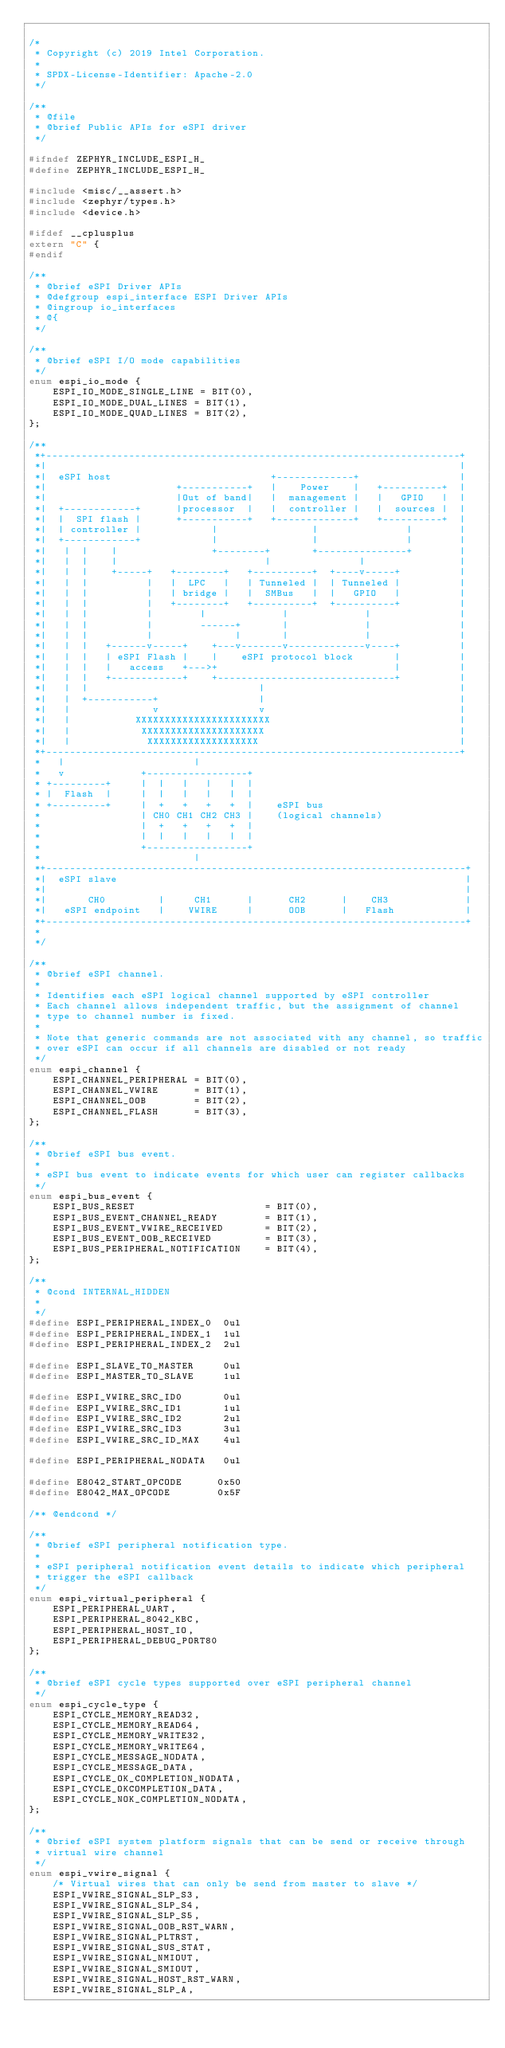Convert code to text. <code><loc_0><loc_0><loc_500><loc_500><_C_>
/*
 * Copyright (c) 2019 Intel Corporation.
 *
 * SPDX-License-Identifier: Apache-2.0
 */

/**
 * @file
 * @brief Public APIs for eSPI driver
 */

#ifndef ZEPHYR_INCLUDE_ESPI_H_
#define ZEPHYR_INCLUDE_ESPI_H_

#include <misc/__assert.h>
#include <zephyr/types.h>
#include <device.h>

#ifdef __cplusplus
extern "C" {
#endif

/**
 * @brief eSPI Driver APIs
 * @defgroup espi_interface ESPI Driver APIs
 * @ingroup io_interfaces
 * @{
 */

/**
 * @brief eSPI I/O mode capabilities
 */
enum espi_io_mode {
	ESPI_IO_MODE_SINGLE_LINE = BIT(0),
	ESPI_IO_MODE_DUAL_LINES = BIT(1),
	ESPI_IO_MODE_QUAD_LINES = BIT(2),
};

/**
 *+----------------------------------------------------------------------+
 *|                                                                      |
 *|  eSPI host                           +-------------+                 |
 *|                      +-----------+   |    Power    |   +----------+  |
 *|                      |Out of band|   |  management |   |   GPIO   |  |
 *|  +------------+      |processor  |   |  controller |   |  sources |  |
 *|  |  SPI flash |      +-----------+   +-------------+   +----------+  |
 *|  | controller |            |                |               |        |
 *|  +------------+            |                |               |        |
 *|   |  |    |                +--------+       +---------------+        |
 *|   |  |    |                         |               |                |
 *|   |  |    +-----+   +--------+   +----------+  +----v-----+          |
 *|   |  |          |   |  LPC   |   | Tunneled |  | Tunneled |          |
 *|   |  |          |   | bridge |   |  SMBus   |  |   GPIO   |          |
 *|   |  |          |   +--------+   +----------+  +----------+          |
 *|   |  |          |        |             |             |               |
 *|   |  |          |        ------+       |             |               |
 *|   |  |          |              |       |             |               |
 *|   |  |   +------v-----+    +---v-------v-------------v----+          |
 *|   |  |   | eSPI Flash |    |    eSPI protocol block       |          |
 *|   |  |   |   access   +--->+                              |          |
 *|   |  |   +------------+    +------------------------------+          |
 *|   |  |                             |                                 |
 *|   |  +-----------+                 |                                 |
 *|   |              v                 v                                 |
 *|   |           XXXXXXXXXXXXXXXXXXXXXXX                                |
 *|   |            XXXXXXXXXXXXXXXXXXXXX                                 |
 *|   |             XXXXXXXXXXXXXXXXXXX                                  |
 *+----------------------------------------------------------------------+
 *   |                      |
 *   v             +-----------------+
 * +---------+     |  |   |   |   |  |
 * |  Flash  |     |  |   |   |   |  |
 * +---------+     |  +   +   +   +  |    eSPI bus
 *                 | CH0 CH1 CH2 CH3 |    (logical channels)
 *                 |  +   +   +   +  |
 *                 |  |   |   |   |  |
 *                 +-----------------+
 *                          |
 *+-----------------------------------------------------------------------+
 *|  eSPI slave                                                           |
 *|                                                                       |
 *|       CH0         |     CH1      |      CH2      |    CH3             |
 *|   eSPI endpoint   |    VWIRE     |      OOB      |   Flash            |
 *+-----------------------------------------------------------------------+
 *
 */

/**
 * @brief eSPI channel.
 *
 * Identifies each eSPI logical channel supported by eSPI controller
 * Each channel allows independent traffic, but the assignment of channel
 * type to channel number is fixed.
 *
 * Note that generic commands are not associated with any channel, so traffic
 * over eSPI can occur if all channels are disabled or not ready
 */
enum espi_channel {
	ESPI_CHANNEL_PERIPHERAL = BIT(0),
	ESPI_CHANNEL_VWIRE      = BIT(1),
	ESPI_CHANNEL_OOB        = BIT(2),
	ESPI_CHANNEL_FLASH      = BIT(3),
};

/**
 * @brief eSPI bus event.
 *
 * eSPI bus event to indicate events for which user can register callbacks
 */
enum espi_bus_event {
	ESPI_BUS_RESET                      = BIT(0),
	ESPI_BUS_EVENT_CHANNEL_READY        = BIT(1),
	ESPI_BUS_EVENT_VWIRE_RECEIVED       = BIT(2),
	ESPI_BUS_EVENT_OOB_RECEIVED         = BIT(3),
	ESPI_BUS_PERIPHERAL_NOTIFICATION    = BIT(4),
};

/**
 * @cond INTERNAL_HIDDEN
 *
 */
#define ESPI_PERIPHERAL_INDEX_0  0ul
#define ESPI_PERIPHERAL_INDEX_1  1ul
#define ESPI_PERIPHERAL_INDEX_2  2ul

#define ESPI_SLAVE_TO_MASTER     0ul
#define ESPI_MASTER_TO_SLAVE     1ul

#define ESPI_VWIRE_SRC_ID0       0ul
#define ESPI_VWIRE_SRC_ID1       1ul
#define ESPI_VWIRE_SRC_ID2       2ul
#define ESPI_VWIRE_SRC_ID3       3ul
#define ESPI_VWIRE_SRC_ID_MAX    4ul

#define ESPI_PERIPHERAL_NODATA   0ul

#define E8042_START_OPCODE      0x50
#define E8042_MAX_OPCODE        0x5F

/** @endcond */

/**
 * @brief eSPI peripheral notification type.
 *
 * eSPI peripheral notification event details to indicate which peripheral
 * trigger the eSPI callback
 */
enum espi_virtual_peripheral {
	ESPI_PERIPHERAL_UART,
	ESPI_PERIPHERAL_8042_KBC,
	ESPI_PERIPHERAL_HOST_IO,
	ESPI_PERIPHERAL_DEBUG_PORT80
};

/**
 * @brief eSPI cycle types supported over eSPI peripheral channel
 */
enum espi_cycle_type {
	ESPI_CYCLE_MEMORY_READ32,
	ESPI_CYCLE_MEMORY_READ64,
	ESPI_CYCLE_MEMORY_WRITE32,
	ESPI_CYCLE_MEMORY_WRITE64,
	ESPI_CYCLE_MESSAGE_NODATA,
	ESPI_CYCLE_MESSAGE_DATA,
	ESPI_CYCLE_OK_COMPLETION_NODATA,
	ESPI_CYCLE_OKCOMPLETION_DATA,
	ESPI_CYCLE_NOK_COMPLETION_NODATA,
};

/**
 * @brief eSPI system platform signals that can be send or receive through
 * virtual wire channel
 */
enum espi_vwire_signal {
	/* Virtual wires that can only be send from master to slave */
	ESPI_VWIRE_SIGNAL_SLP_S3,
	ESPI_VWIRE_SIGNAL_SLP_S4,
	ESPI_VWIRE_SIGNAL_SLP_S5,
	ESPI_VWIRE_SIGNAL_OOB_RST_WARN,
	ESPI_VWIRE_SIGNAL_PLTRST,
	ESPI_VWIRE_SIGNAL_SUS_STAT,
	ESPI_VWIRE_SIGNAL_NMIOUT,
	ESPI_VWIRE_SIGNAL_SMIOUT,
	ESPI_VWIRE_SIGNAL_HOST_RST_WARN,
	ESPI_VWIRE_SIGNAL_SLP_A,</code> 